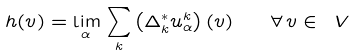Convert formula to latex. <formula><loc_0><loc_0><loc_500><loc_500>h ( v ) = \lim _ { \alpha } \, \sum _ { k } \left ( \Delta ^ { * } _ { k } u _ { \alpha } ^ { k } \right ) ( v ) \quad \forall \, v \in \ V</formula> 